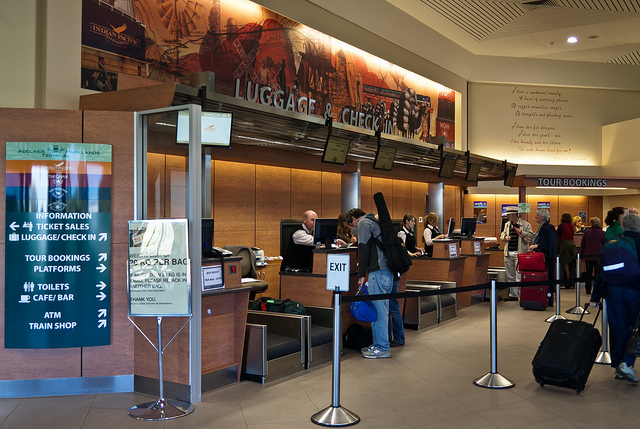Can you tell me what services are offered at this location? The signage in the image suggests a variety of services offered at this location, including information, ticket sales, luggage check-in, tour bookings, platform access, toilets, a café bar, an ATM, and a train shop, making this a well-equipped train station. 